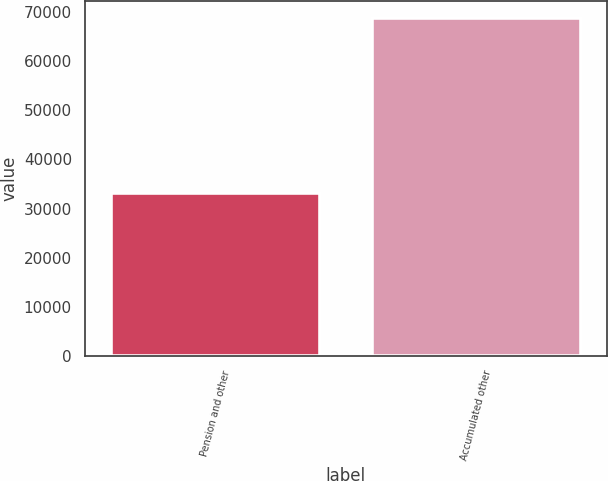Convert chart to OTSL. <chart><loc_0><loc_0><loc_500><loc_500><bar_chart><fcel>Pension and other<fcel>Accumulated other<nl><fcel>33129<fcel>68822<nl></chart> 